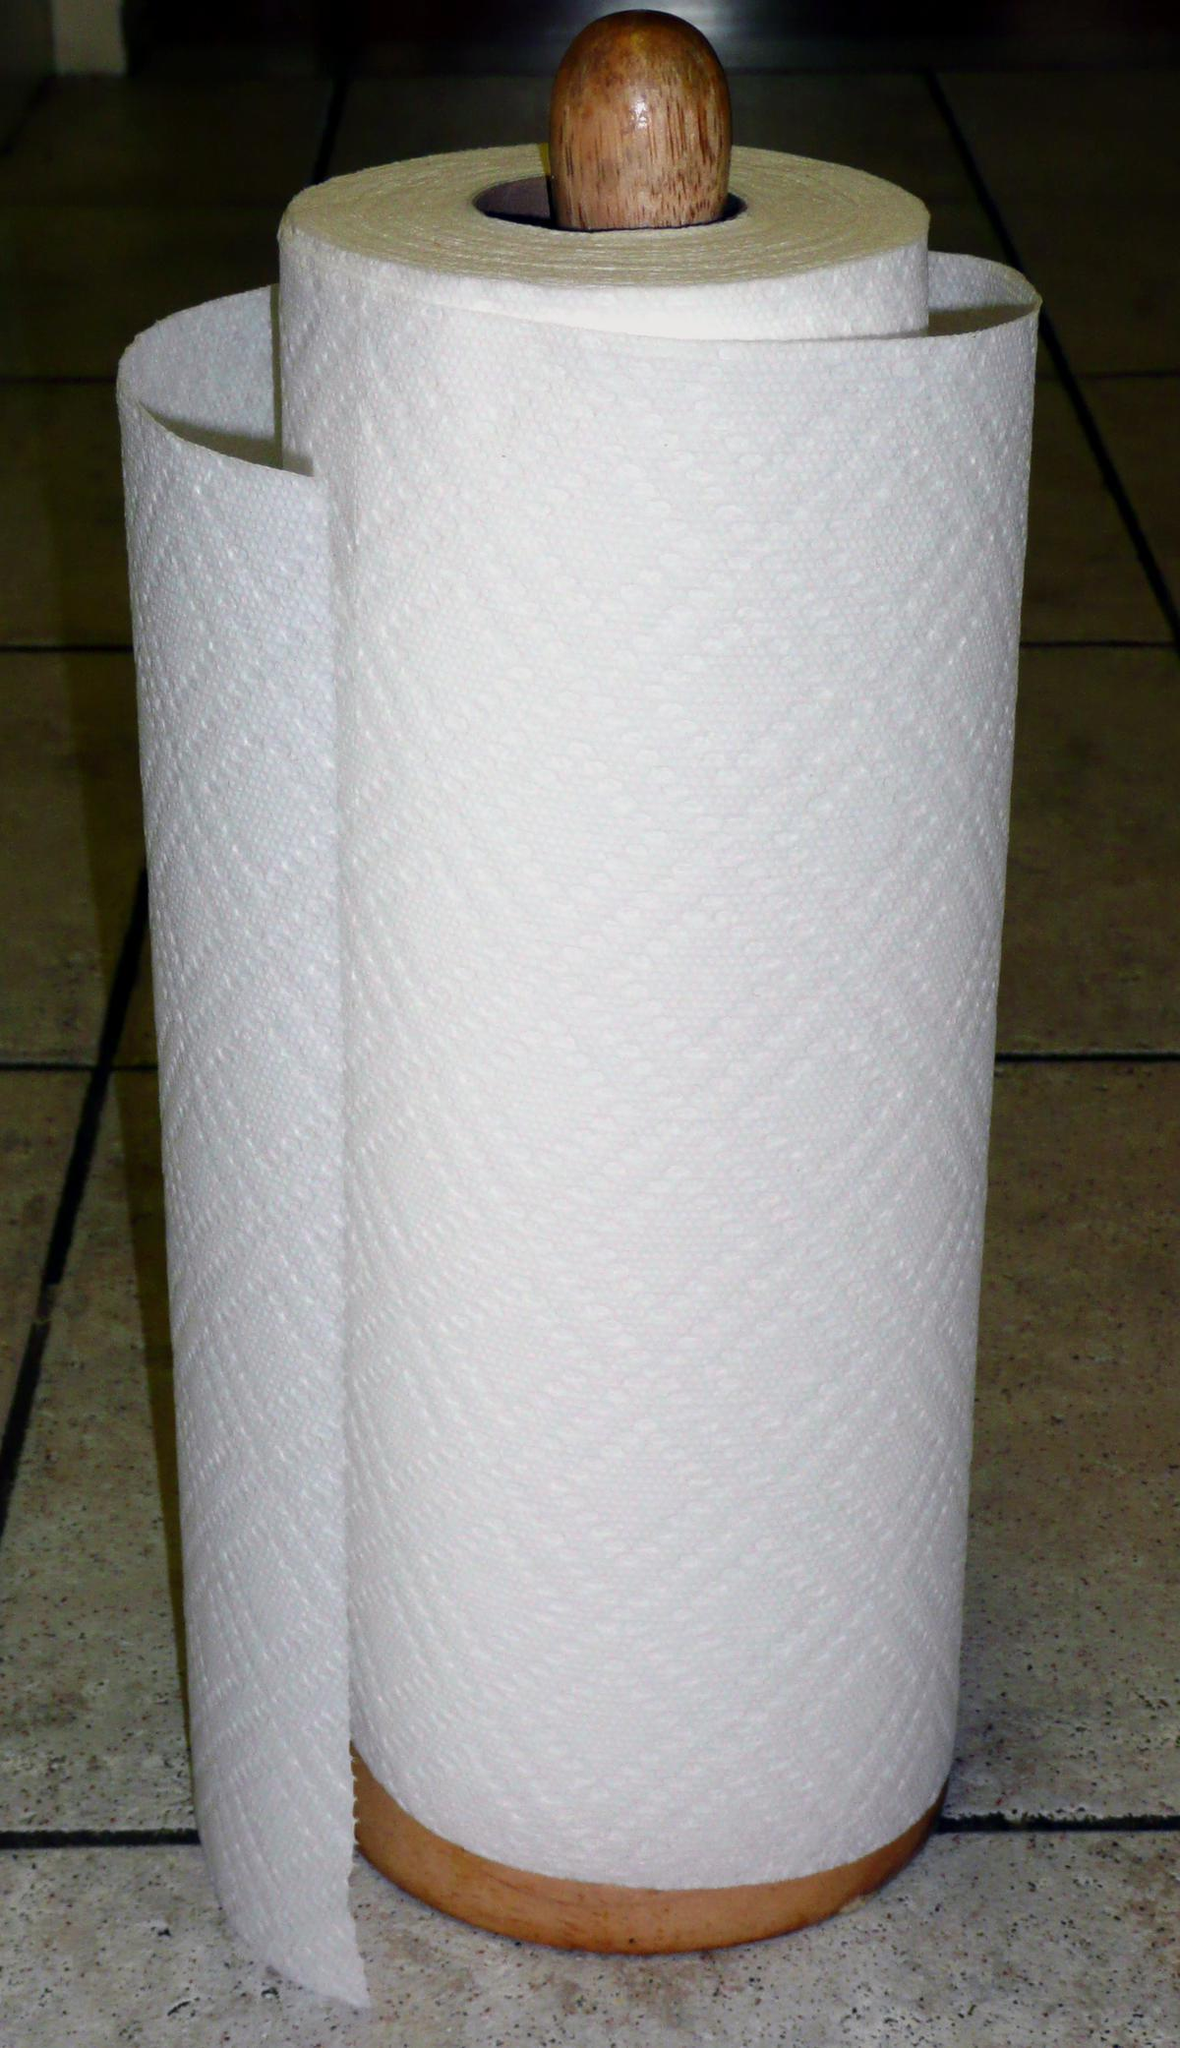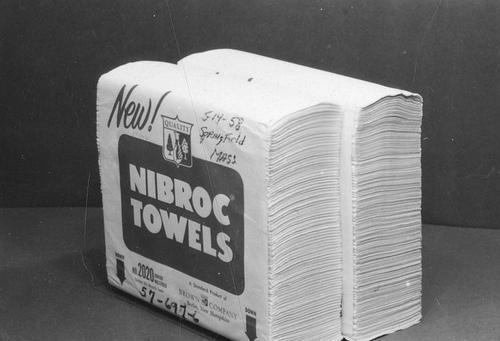The first image is the image on the left, the second image is the image on the right. For the images shown, is this caption "The left image contains a paper towel stand." true? Answer yes or no. Yes. 